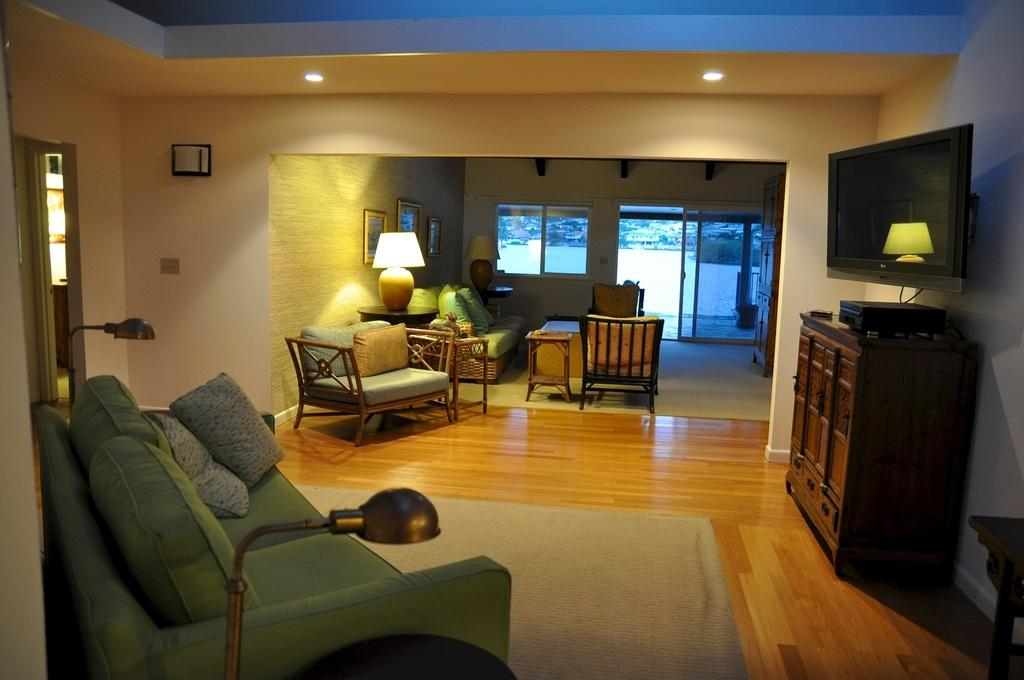What type of furniture is in the image? There is a couch in the image. How many pillows are on the couch? The couch has two pillows. What type of electronic device is in the image? There is a television in the image. Where is the television positioned in the image? The television is on the night in the image. What type of appliance is needed to operate the industry in the image? There is no reference to an appliance, need, or industry in the image. 